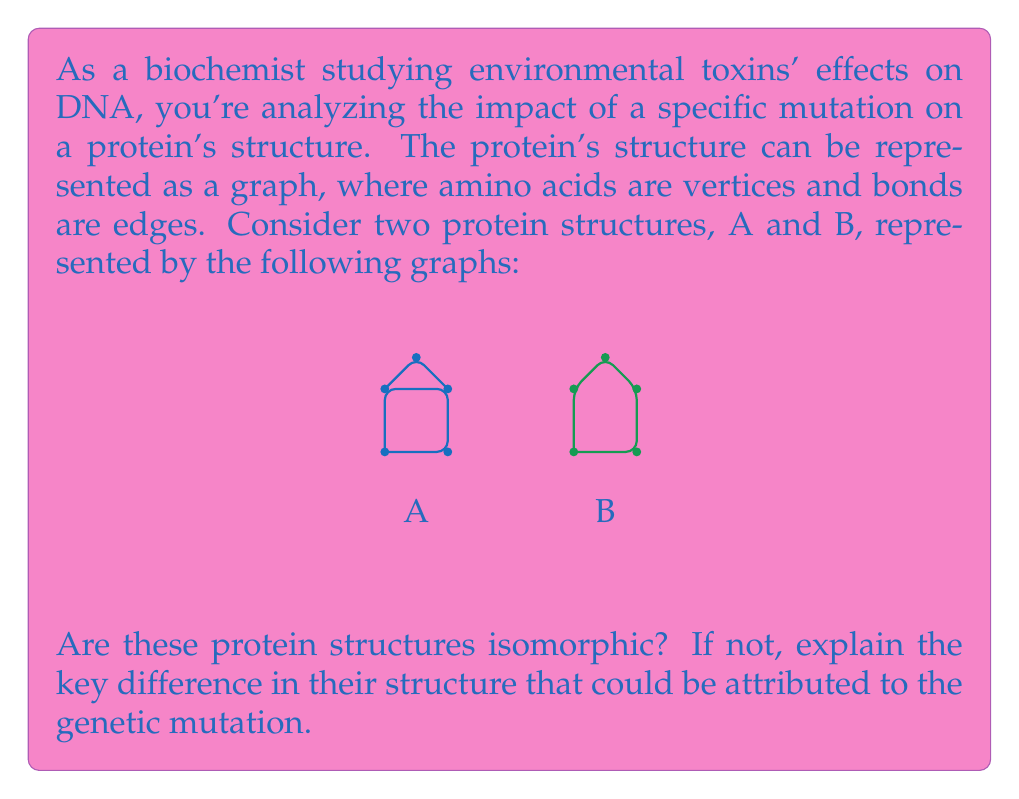Can you solve this math problem? To determine if the protein structures A and B are isomorphic, we need to analyze their graph representations:

1. Count vertices and edges:
   - Both graphs have 5 vertices, satisfying the first condition for isomorphism.
   - Graph A has 6 edges, while Graph B has 5 edges.

2. Since the number of edges differs, we can immediately conclude that the graphs are not isomorphic.

3. Key structural difference:
   - Graph A contains a cycle of length 4 (square shape) with an additional vertex connected to two opposite corners of the square.
   - Graph B contains a cycle of length 5 (pentagon shape).

4. Biochemical interpretation:
   - The difference in structure suggests that the genetic mutation has altered the bonding pattern between amino acids.
   - In structure A, there's a more compact core (the square) with a protruding element, while structure B has a more uniform, circular arrangement.

5. Possible effects of the mutation:
   - The change in structure could affect the protein's function, stability, or interaction with other molecules.
   - The more open structure of B might expose different amino acids to the environment, potentially altering the protein's reactivity or binding properties.

In graph theory terms, the key difference is in the cycle structure and edge connectivity, which translates to different bonding patterns in the protein structures.
Answer: Not isomorphic; A has a 4-cycle core, B has a 5-cycle structure. 